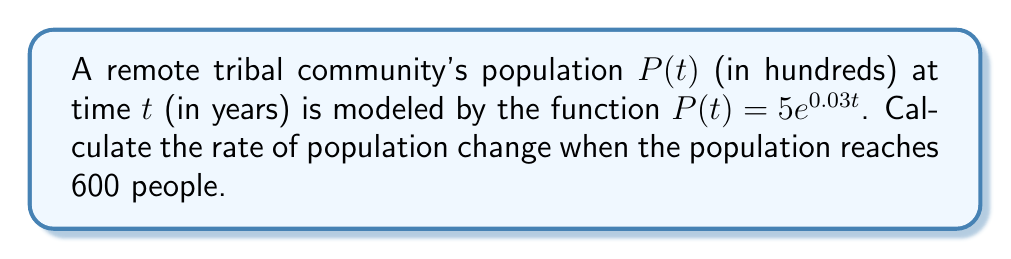Show me your answer to this math problem. To solve this problem, we'll follow these steps:

1) The rate of population change is given by the derivative of $P(t)$ with respect to $t$:

   $$\frac{dP}{dt} = 5 \cdot 0.03e^{0.03t} = 0.15e^{0.03t}$$

2) We need to find $t$ when $P(t) = 600$ people, or 6 hundreds:

   $$5e^{0.03t} = 6$$

3) Solving for $t$:

   $$e^{0.03t} = \frac{6}{5}$$
   $$0.03t = \ln(\frac{6}{5})$$
   $$t = \frac{\ln(\frac{6}{5})}{0.03} \approx 6.27 \text{ years}$$

4) Now, we substitute this $t$ value into the derivative:

   $$\frac{dP}{dt} = 0.15e^{0.03(6.27)} = 0.15 \cdot \frac{6}{5} = 0.18$$

5) Convert to people per year:

   $$0.18 \cdot 100 = 18 \text{ people/year}$$
Answer: $18$ people/year 